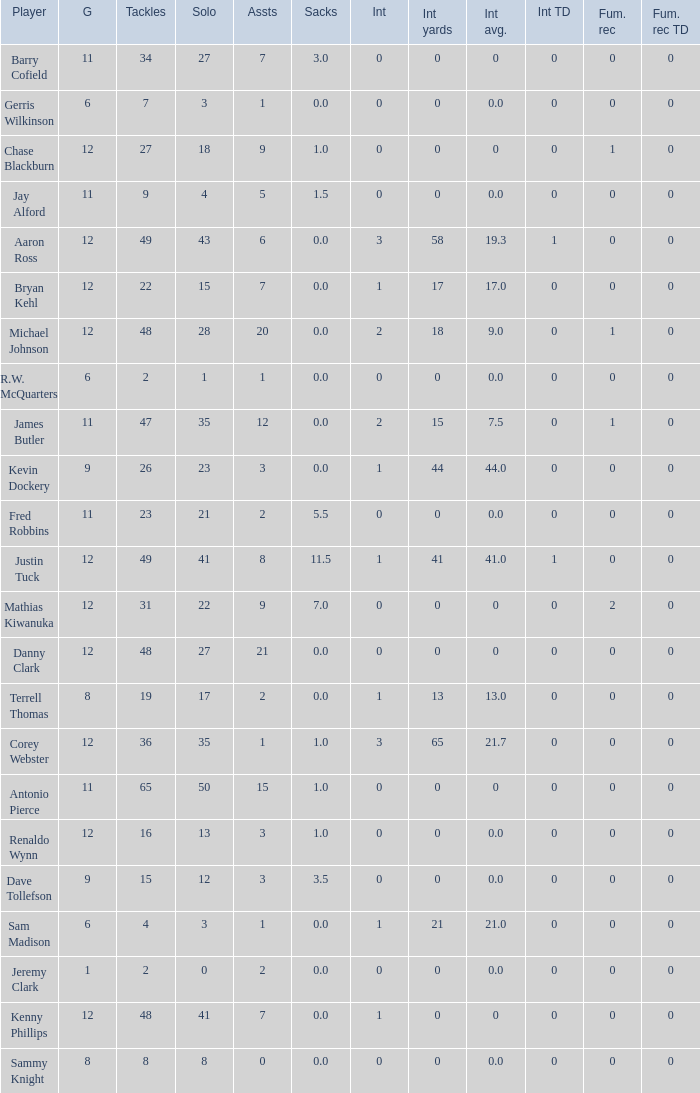Name the least int yards when sacks is 11.5 41.0. 